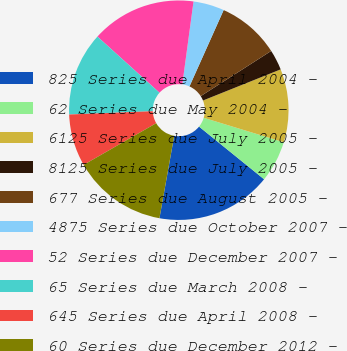<chart> <loc_0><loc_0><loc_500><loc_500><pie_chart><fcel>825 Series due April 2004 -<fcel>62 Series due May 2004 -<fcel>6125 Series due July 2005 -<fcel>8125 Series due July 2005 -<fcel>677 Series due August 2005 -<fcel>4875 Series due October 2007 -<fcel>52 Series due December 2007 -<fcel>65 Series due March 2008 -<fcel>645 Series due April 2008 -<fcel>60 Series due December 2012 -<nl><fcel>16.99%<fcel>6.12%<fcel>10.78%<fcel>3.01%<fcel>9.22%<fcel>4.56%<fcel>15.44%<fcel>12.33%<fcel>7.67%<fcel>13.88%<nl></chart> 